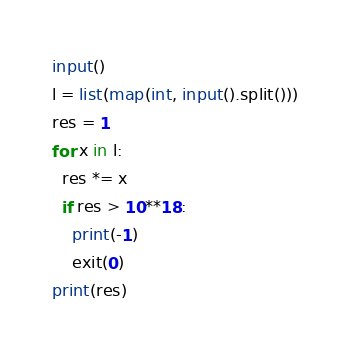<code> <loc_0><loc_0><loc_500><loc_500><_Python_>input()
l = list(map(int, input().split()))
res = 1
for x in l:
  res *= x
  if res > 10**18:
    print(-1)
    exit(0)
print(res)</code> 